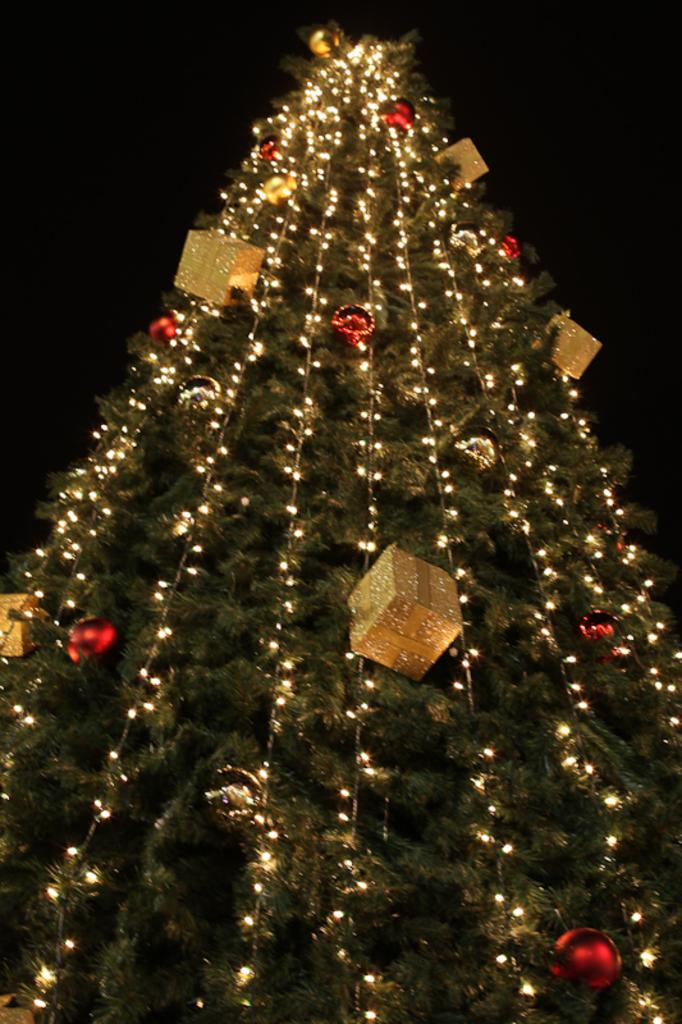What type of tree is featured in the image? There is a Christmas tree in the image. How is the Christmas tree decorated? The Christmas tree is fully decorated, including lights. Are there any additional decorations on the tree? Yes, there are gift boxes on the Christmas tree. What type of gold branch can be seen on the Christmas tree? There is no gold branch present on the Christmas tree in the image. 